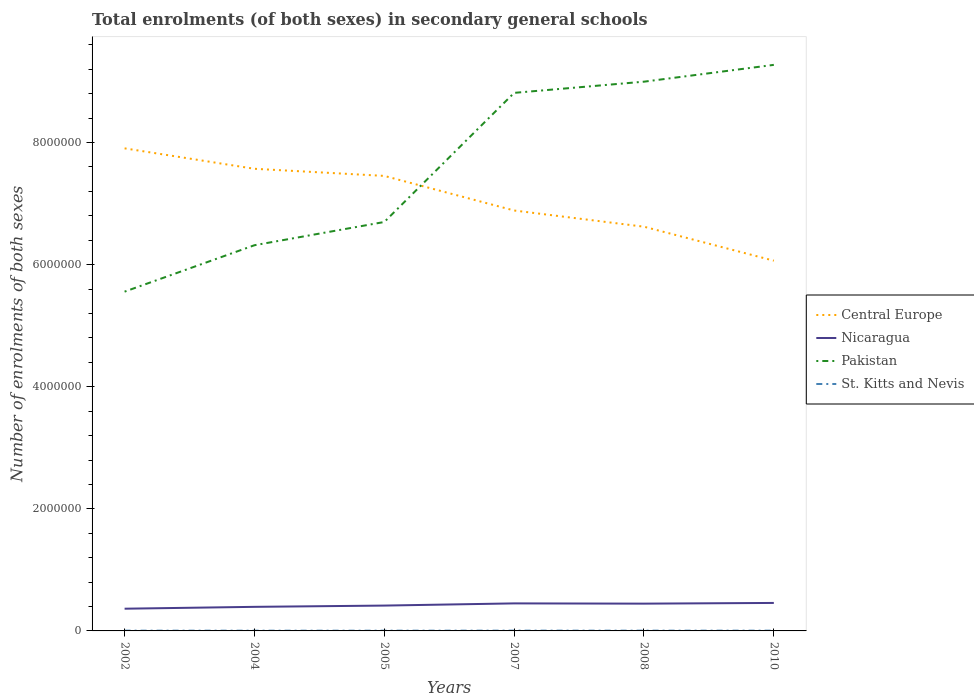Is the number of lines equal to the number of legend labels?
Give a very brief answer. Yes. Across all years, what is the maximum number of enrolments in secondary schools in Central Europe?
Your response must be concise. 6.07e+06. In which year was the number of enrolments in secondary schools in St. Kitts and Nevis maximum?
Provide a succinct answer. 2004. What is the total number of enrolments in secondary schools in Pakistan in the graph?
Offer a very short reply. -1.14e+06. What is the difference between the highest and the second highest number of enrolments in secondary schools in Pakistan?
Give a very brief answer. 3.72e+06. How many lines are there?
Your answer should be very brief. 4. Does the graph contain grids?
Give a very brief answer. No. Where does the legend appear in the graph?
Make the answer very short. Center right. How are the legend labels stacked?
Give a very brief answer. Vertical. What is the title of the graph?
Ensure brevity in your answer.  Total enrolments (of both sexes) in secondary general schools. Does "Vanuatu" appear as one of the legend labels in the graph?
Make the answer very short. No. What is the label or title of the X-axis?
Your answer should be very brief. Years. What is the label or title of the Y-axis?
Keep it short and to the point. Number of enrolments of both sexes. What is the Number of enrolments of both sexes in Central Europe in 2002?
Make the answer very short. 7.91e+06. What is the Number of enrolments of both sexes in Nicaragua in 2002?
Keep it short and to the point. 3.64e+05. What is the Number of enrolments of both sexes in Pakistan in 2002?
Offer a very short reply. 5.56e+06. What is the Number of enrolments of both sexes in St. Kitts and Nevis in 2002?
Your response must be concise. 4240. What is the Number of enrolments of both sexes in Central Europe in 2004?
Offer a very short reply. 7.57e+06. What is the Number of enrolments of both sexes in Nicaragua in 2004?
Keep it short and to the point. 3.94e+05. What is the Number of enrolments of both sexes in Pakistan in 2004?
Your response must be concise. 6.32e+06. What is the Number of enrolments of both sexes of St. Kitts and Nevis in 2004?
Provide a succinct answer. 3903. What is the Number of enrolments of both sexes in Central Europe in 2005?
Your answer should be very brief. 7.45e+06. What is the Number of enrolments of both sexes in Nicaragua in 2005?
Your answer should be very brief. 4.15e+05. What is the Number of enrolments of both sexes of Pakistan in 2005?
Provide a succinct answer. 6.70e+06. What is the Number of enrolments of both sexes of St. Kitts and Nevis in 2005?
Offer a terse response. 3939. What is the Number of enrolments of both sexes in Central Europe in 2007?
Keep it short and to the point. 6.89e+06. What is the Number of enrolments of both sexes of Nicaragua in 2007?
Keep it short and to the point. 4.51e+05. What is the Number of enrolments of both sexes in Pakistan in 2007?
Give a very brief answer. 8.81e+06. What is the Number of enrolments of both sexes in St. Kitts and Nevis in 2007?
Offer a very short reply. 4522. What is the Number of enrolments of both sexes of Central Europe in 2008?
Make the answer very short. 6.62e+06. What is the Number of enrolments of both sexes of Nicaragua in 2008?
Provide a short and direct response. 4.47e+05. What is the Number of enrolments of both sexes of Pakistan in 2008?
Provide a succinct answer. 9.00e+06. What is the Number of enrolments of both sexes of St. Kitts and Nevis in 2008?
Make the answer very short. 4396. What is the Number of enrolments of both sexes of Central Europe in 2010?
Keep it short and to the point. 6.07e+06. What is the Number of enrolments of both sexes in Nicaragua in 2010?
Offer a terse response. 4.58e+05. What is the Number of enrolments of both sexes in Pakistan in 2010?
Offer a terse response. 9.27e+06. What is the Number of enrolments of both sexes in St. Kitts and Nevis in 2010?
Provide a short and direct response. 4309. Across all years, what is the maximum Number of enrolments of both sexes in Central Europe?
Your response must be concise. 7.91e+06. Across all years, what is the maximum Number of enrolments of both sexes in Nicaragua?
Make the answer very short. 4.58e+05. Across all years, what is the maximum Number of enrolments of both sexes in Pakistan?
Your answer should be very brief. 9.27e+06. Across all years, what is the maximum Number of enrolments of both sexes of St. Kitts and Nevis?
Your answer should be compact. 4522. Across all years, what is the minimum Number of enrolments of both sexes of Central Europe?
Offer a very short reply. 6.07e+06. Across all years, what is the minimum Number of enrolments of both sexes in Nicaragua?
Give a very brief answer. 3.64e+05. Across all years, what is the minimum Number of enrolments of both sexes of Pakistan?
Offer a very short reply. 5.56e+06. Across all years, what is the minimum Number of enrolments of both sexes of St. Kitts and Nevis?
Keep it short and to the point. 3903. What is the total Number of enrolments of both sexes in Central Europe in the graph?
Offer a very short reply. 4.25e+07. What is the total Number of enrolments of both sexes in Nicaragua in the graph?
Offer a very short reply. 2.53e+06. What is the total Number of enrolments of both sexes of Pakistan in the graph?
Provide a succinct answer. 4.57e+07. What is the total Number of enrolments of both sexes in St. Kitts and Nevis in the graph?
Make the answer very short. 2.53e+04. What is the difference between the Number of enrolments of both sexes in Central Europe in 2002 and that in 2004?
Your answer should be very brief. 3.35e+05. What is the difference between the Number of enrolments of both sexes of Nicaragua in 2002 and that in 2004?
Your response must be concise. -3.03e+04. What is the difference between the Number of enrolments of both sexes of Pakistan in 2002 and that in 2004?
Ensure brevity in your answer.  -7.60e+05. What is the difference between the Number of enrolments of both sexes of St. Kitts and Nevis in 2002 and that in 2004?
Offer a very short reply. 337. What is the difference between the Number of enrolments of both sexes in Central Europe in 2002 and that in 2005?
Give a very brief answer. 4.51e+05. What is the difference between the Number of enrolments of both sexes of Nicaragua in 2002 and that in 2005?
Your response must be concise. -5.13e+04. What is the difference between the Number of enrolments of both sexes in Pakistan in 2002 and that in 2005?
Your response must be concise. -1.14e+06. What is the difference between the Number of enrolments of both sexes in St. Kitts and Nevis in 2002 and that in 2005?
Keep it short and to the point. 301. What is the difference between the Number of enrolments of both sexes of Central Europe in 2002 and that in 2007?
Your response must be concise. 1.02e+06. What is the difference between the Number of enrolments of both sexes of Nicaragua in 2002 and that in 2007?
Your answer should be very brief. -8.71e+04. What is the difference between the Number of enrolments of both sexes of Pakistan in 2002 and that in 2007?
Offer a very short reply. -3.26e+06. What is the difference between the Number of enrolments of both sexes of St. Kitts and Nevis in 2002 and that in 2007?
Offer a terse response. -282. What is the difference between the Number of enrolments of both sexes of Central Europe in 2002 and that in 2008?
Provide a short and direct response. 1.28e+06. What is the difference between the Number of enrolments of both sexes of Nicaragua in 2002 and that in 2008?
Ensure brevity in your answer.  -8.29e+04. What is the difference between the Number of enrolments of both sexes of Pakistan in 2002 and that in 2008?
Your response must be concise. -3.44e+06. What is the difference between the Number of enrolments of both sexes of St. Kitts and Nevis in 2002 and that in 2008?
Keep it short and to the point. -156. What is the difference between the Number of enrolments of both sexes in Central Europe in 2002 and that in 2010?
Your answer should be very brief. 1.84e+06. What is the difference between the Number of enrolments of both sexes of Nicaragua in 2002 and that in 2010?
Make the answer very short. -9.43e+04. What is the difference between the Number of enrolments of both sexes in Pakistan in 2002 and that in 2010?
Provide a succinct answer. -3.72e+06. What is the difference between the Number of enrolments of both sexes of St. Kitts and Nevis in 2002 and that in 2010?
Offer a terse response. -69. What is the difference between the Number of enrolments of both sexes in Central Europe in 2004 and that in 2005?
Your response must be concise. 1.17e+05. What is the difference between the Number of enrolments of both sexes in Nicaragua in 2004 and that in 2005?
Ensure brevity in your answer.  -2.09e+04. What is the difference between the Number of enrolments of both sexes in Pakistan in 2004 and that in 2005?
Ensure brevity in your answer.  -3.81e+05. What is the difference between the Number of enrolments of both sexes of St. Kitts and Nevis in 2004 and that in 2005?
Keep it short and to the point. -36. What is the difference between the Number of enrolments of both sexes in Central Europe in 2004 and that in 2007?
Offer a very short reply. 6.83e+05. What is the difference between the Number of enrolments of both sexes of Nicaragua in 2004 and that in 2007?
Keep it short and to the point. -5.67e+04. What is the difference between the Number of enrolments of both sexes in Pakistan in 2004 and that in 2007?
Provide a succinct answer. -2.50e+06. What is the difference between the Number of enrolments of both sexes of St. Kitts and Nevis in 2004 and that in 2007?
Provide a succinct answer. -619. What is the difference between the Number of enrolments of both sexes in Central Europe in 2004 and that in 2008?
Your answer should be very brief. 9.49e+05. What is the difference between the Number of enrolments of both sexes of Nicaragua in 2004 and that in 2008?
Your answer should be very brief. -5.25e+04. What is the difference between the Number of enrolments of both sexes of Pakistan in 2004 and that in 2008?
Ensure brevity in your answer.  -2.68e+06. What is the difference between the Number of enrolments of both sexes of St. Kitts and Nevis in 2004 and that in 2008?
Offer a terse response. -493. What is the difference between the Number of enrolments of both sexes of Central Europe in 2004 and that in 2010?
Offer a terse response. 1.51e+06. What is the difference between the Number of enrolments of both sexes in Nicaragua in 2004 and that in 2010?
Make the answer very short. -6.40e+04. What is the difference between the Number of enrolments of both sexes in Pakistan in 2004 and that in 2010?
Provide a succinct answer. -2.95e+06. What is the difference between the Number of enrolments of both sexes of St. Kitts and Nevis in 2004 and that in 2010?
Make the answer very short. -406. What is the difference between the Number of enrolments of both sexes in Central Europe in 2005 and that in 2007?
Offer a terse response. 5.67e+05. What is the difference between the Number of enrolments of both sexes in Nicaragua in 2005 and that in 2007?
Your answer should be compact. -3.58e+04. What is the difference between the Number of enrolments of both sexes in Pakistan in 2005 and that in 2007?
Offer a very short reply. -2.12e+06. What is the difference between the Number of enrolments of both sexes in St. Kitts and Nevis in 2005 and that in 2007?
Give a very brief answer. -583. What is the difference between the Number of enrolments of both sexes in Central Europe in 2005 and that in 2008?
Keep it short and to the point. 8.32e+05. What is the difference between the Number of enrolments of both sexes of Nicaragua in 2005 and that in 2008?
Offer a terse response. -3.16e+04. What is the difference between the Number of enrolments of both sexes of Pakistan in 2005 and that in 2008?
Keep it short and to the point. -2.30e+06. What is the difference between the Number of enrolments of both sexes in St. Kitts and Nevis in 2005 and that in 2008?
Provide a succinct answer. -457. What is the difference between the Number of enrolments of both sexes of Central Europe in 2005 and that in 2010?
Your response must be concise. 1.39e+06. What is the difference between the Number of enrolments of both sexes in Nicaragua in 2005 and that in 2010?
Your response must be concise. -4.30e+04. What is the difference between the Number of enrolments of both sexes of Pakistan in 2005 and that in 2010?
Offer a very short reply. -2.57e+06. What is the difference between the Number of enrolments of both sexes of St. Kitts and Nevis in 2005 and that in 2010?
Keep it short and to the point. -370. What is the difference between the Number of enrolments of both sexes in Central Europe in 2007 and that in 2008?
Keep it short and to the point. 2.65e+05. What is the difference between the Number of enrolments of both sexes in Nicaragua in 2007 and that in 2008?
Offer a terse response. 4215. What is the difference between the Number of enrolments of both sexes in Pakistan in 2007 and that in 2008?
Keep it short and to the point. -1.83e+05. What is the difference between the Number of enrolments of both sexes in St. Kitts and Nevis in 2007 and that in 2008?
Your answer should be compact. 126. What is the difference between the Number of enrolments of both sexes of Central Europe in 2007 and that in 2010?
Offer a terse response. 8.22e+05. What is the difference between the Number of enrolments of both sexes of Nicaragua in 2007 and that in 2010?
Keep it short and to the point. -7238. What is the difference between the Number of enrolments of both sexes of Pakistan in 2007 and that in 2010?
Offer a terse response. -4.59e+05. What is the difference between the Number of enrolments of both sexes of St. Kitts and Nevis in 2007 and that in 2010?
Make the answer very short. 213. What is the difference between the Number of enrolments of both sexes in Central Europe in 2008 and that in 2010?
Your answer should be very brief. 5.57e+05. What is the difference between the Number of enrolments of both sexes in Nicaragua in 2008 and that in 2010?
Ensure brevity in your answer.  -1.15e+04. What is the difference between the Number of enrolments of both sexes of Pakistan in 2008 and that in 2010?
Give a very brief answer. -2.75e+05. What is the difference between the Number of enrolments of both sexes of Central Europe in 2002 and the Number of enrolments of both sexes of Nicaragua in 2004?
Provide a succinct answer. 7.51e+06. What is the difference between the Number of enrolments of both sexes of Central Europe in 2002 and the Number of enrolments of both sexes of Pakistan in 2004?
Keep it short and to the point. 1.59e+06. What is the difference between the Number of enrolments of both sexes in Central Europe in 2002 and the Number of enrolments of both sexes in St. Kitts and Nevis in 2004?
Offer a terse response. 7.90e+06. What is the difference between the Number of enrolments of both sexes of Nicaragua in 2002 and the Number of enrolments of both sexes of Pakistan in 2004?
Your answer should be very brief. -5.95e+06. What is the difference between the Number of enrolments of both sexes of Nicaragua in 2002 and the Number of enrolments of both sexes of St. Kitts and Nevis in 2004?
Provide a succinct answer. 3.60e+05. What is the difference between the Number of enrolments of both sexes of Pakistan in 2002 and the Number of enrolments of both sexes of St. Kitts and Nevis in 2004?
Offer a terse response. 5.55e+06. What is the difference between the Number of enrolments of both sexes in Central Europe in 2002 and the Number of enrolments of both sexes in Nicaragua in 2005?
Your response must be concise. 7.49e+06. What is the difference between the Number of enrolments of both sexes in Central Europe in 2002 and the Number of enrolments of both sexes in Pakistan in 2005?
Ensure brevity in your answer.  1.21e+06. What is the difference between the Number of enrolments of both sexes in Central Europe in 2002 and the Number of enrolments of both sexes in St. Kitts and Nevis in 2005?
Keep it short and to the point. 7.90e+06. What is the difference between the Number of enrolments of both sexes in Nicaragua in 2002 and the Number of enrolments of both sexes in Pakistan in 2005?
Keep it short and to the point. -6.34e+06. What is the difference between the Number of enrolments of both sexes in Nicaragua in 2002 and the Number of enrolments of both sexes in St. Kitts and Nevis in 2005?
Your response must be concise. 3.60e+05. What is the difference between the Number of enrolments of both sexes in Pakistan in 2002 and the Number of enrolments of both sexes in St. Kitts and Nevis in 2005?
Offer a very short reply. 5.55e+06. What is the difference between the Number of enrolments of both sexes of Central Europe in 2002 and the Number of enrolments of both sexes of Nicaragua in 2007?
Your answer should be very brief. 7.45e+06. What is the difference between the Number of enrolments of both sexes in Central Europe in 2002 and the Number of enrolments of both sexes in Pakistan in 2007?
Provide a short and direct response. -9.09e+05. What is the difference between the Number of enrolments of both sexes in Central Europe in 2002 and the Number of enrolments of both sexes in St. Kitts and Nevis in 2007?
Ensure brevity in your answer.  7.90e+06. What is the difference between the Number of enrolments of both sexes of Nicaragua in 2002 and the Number of enrolments of both sexes of Pakistan in 2007?
Your answer should be compact. -8.45e+06. What is the difference between the Number of enrolments of both sexes of Nicaragua in 2002 and the Number of enrolments of both sexes of St. Kitts and Nevis in 2007?
Your answer should be compact. 3.59e+05. What is the difference between the Number of enrolments of both sexes in Pakistan in 2002 and the Number of enrolments of both sexes in St. Kitts and Nevis in 2007?
Your answer should be very brief. 5.55e+06. What is the difference between the Number of enrolments of both sexes of Central Europe in 2002 and the Number of enrolments of both sexes of Nicaragua in 2008?
Offer a terse response. 7.46e+06. What is the difference between the Number of enrolments of both sexes in Central Europe in 2002 and the Number of enrolments of both sexes in Pakistan in 2008?
Your answer should be very brief. -1.09e+06. What is the difference between the Number of enrolments of both sexes of Central Europe in 2002 and the Number of enrolments of both sexes of St. Kitts and Nevis in 2008?
Keep it short and to the point. 7.90e+06. What is the difference between the Number of enrolments of both sexes of Nicaragua in 2002 and the Number of enrolments of both sexes of Pakistan in 2008?
Ensure brevity in your answer.  -8.63e+06. What is the difference between the Number of enrolments of both sexes in Nicaragua in 2002 and the Number of enrolments of both sexes in St. Kitts and Nevis in 2008?
Your answer should be very brief. 3.60e+05. What is the difference between the Number of enrolments of both sexes in Pakistan in 2002 and the Number of enrolments of both sexes in St. Kitts and Nevis in 2008?
Your answer should be very brief. 5.55e+06. What is the difference between the Number of enrolments of both sexes in Central Europe in 2002 and the Number of enrolments of both sexes in Nicaragua in 2010?
Your answer should be compact. 7.45e+06. What is the difference between the Number of enrolments of both sexes of Central Europe in 2002 and the Number of enrolments of both sexes of Pakistan in 2010?
Give a very brief answer. -1.37e+06. What is the difference between the Number of enrolments of both sexes in Central Europe in 2002 and the Number of enrolments of both sexes in St. Kitts and Nevis in 2010?
Provide a succinct answer. 7.90e+06. What is the difference between the Number of enrolments of both sexes of Nicaragua in 2002 and the Number of enrolments of both sexes of Pakistan in 2010?
Your answer should be compact. -8.91e+06. What is the difference between the Number of enrolments of both sexes of Nicaragua in 2002 and the Number of enrolments of both sexes of St. Kitts and Nevis in 2010?
Provide a succinct answer. 3.60e+05. What is the difference between the Number of enrolments of both sexes in Pakistan in 2002 and the Number of enrolments of both sexes in St. Kitts and Nevis in 2010?
Your answer should be compact. 5.55e+06. What is the difference between the Number of enrolments of both sexes of Central Europe in 2004 and the Number of enrolments of both sexes of Nicaragua in 2005?
Offer a very short reply. 7.16e+06. What is the difference between the Number of enrolments of both sexes of Central Europe in 2004 and the Number of enrolments of both sexes of Pakistan in 2005?
Give a very brief answer. 8.72e+05. What is the difference between the Number of enrolments of both sexes of Central Europe in 2004 and the Number of enrolments of both sexes of St. Kitts and Nevis in 2005?
Your response must be concise. 7.57e+06. What is the difference between the Number of enrolments of both sexes in Nicaragua in 2004 and the Number of enrolments of both sexes in Pakistan in 2005?
Provide a short and direct response. -6.30e+06. What is the difference between the Number of enrolments of both sexes in Nicaragua in 2004 and the Number of enrolments of both sexes in St. Kitts and Nevis in 2005?
Ensure brevity in your answer.  3.90e+05. What is the difference between the Number of enrolments of both sexes of Pakistan in 2004 and the Number of enrolments of both sexes of St. Kitts and Nevis in 2005?
Your answer should be very brief. 6.31e+06. What is the difference between the Number of enrolments of both sexes of Central Europe in 2004 and the Number of enrolments of both sexes of Nicaragua in 2007?
Make the answer very short. 7.12e+06. What is the difference between the Number of enrolments of both sexes in Central Europe in 2004 and the Number of enrolments of both sexes in Pakistan in 2007?
Give a very brief answer. -1.24e+06. What is the difference between the Number of enrolments of both sexes in Central Europe in 2004 and the Number of enrolments of both sexes in St. Kitts and Nevis in 2007?
Give a very brief answer. 7.57e+06. What is the difference between the Number of enrolments of both sexes of Nicaragua in 2004 and the Number of enrolments of both sexes of Pakistan in 2007?
Provide a succinct answer. -8.42e+06. What is the difference between the Number of enrolments of both sexes in Nicaragua in 2004 and the Number of enrolments of both sexes in St. Kitts and Nevis in 2007?
Keep it short and to the point. 3.90e+05. What is the difference between the Number of enrolments of both sexes of Pakistan in 2004 and the Number of enrolments of both sexes of St. Kitts and Nevis in 2007?
Make the answer very short. 6.31e+06. What is the difference between the Number of enrolments of both sexes in Central Europe in 2004 and the Number of enrolments of both sexes in Nicaragua in 2008?
Ensure brevity in your answer.  7.12e+06. What is the difference between the Number of enrolments of both sexes of Central Europe in 2004 and the Number of enrolments of both sexes of Pakistan in 2008?
Your response must be concise. -1.43e+06. What is the difference between the Number of enrolments of both sexes in Central Europe in 2004 and the Number of enrolments of both sexes in St. Kitts and Nevis in 2008?
Offer a very short reply. 7.57e+06. What is the difference between the Number of enrolments of both sexes of Nicaragua in 2004 and the Number of enrolments of both sexes of Pakistan in 2008?
Your response must be concise. -8.60e+06. What is the difference between the Number of enrolments of both sexes of Nicaragua in 2004 and the Number of enrolments of both sexes of St. Kitts and Nevis in 2008?
Keep it short and to the point. 3.90e+05. What is the difference between the Number of enrolments of both sexes of Pakistan in 2004 and the Number of enrolments of both sexes of St. Kitts and Nevis in 2008?
Provide a short and direct response. 6.31e+06. What is the difference between the Number of enrolments of both sexes of Central Europe in 2004 and the Number of enrolments of both sexes of Nicaragua in 2010?
Provide a short and direct response. 7.11e+06. What is the difference between the Number of enrolments of both sexes of Central Europe in 2004 and the Number of enrolments of both sexes of Pakistan in 2010?
Offer a terse response. -1.70e+06. What is the difference between the Number of enrolments of both sexes in Central Europe in 2004 and the Number of enrolments of both sexes in St. Kitts and Nevis in 2010?
Your answer should be compact. 7.57e+06. What is the difference between the Number of enrolments of both sexes of Nicaragua in 2004 and the Number of enrolments of both sexes of Pakistan in 2010?
Provide a short and direct response. -8.88e+06. What is the difference between the Number of enrolments of both sexes in Nicaragua in 2004 and the Number of enrolments of both sexes in St. Kitts and Nevis in 2010?
Your answer should be very brief. 3.90e+05. What is the difference between the Number of enrolments of both sexes of Pakistan in 2004 and the Number of enrolments of both sexes of St. Kitts and Nevis in 2010?
Offer a very short reply. 6.31e+06. What is the difference between the Number of enrolments of both sexes in Central Europe in 2005 and the Number of enrolments of both sexes in Nicaragua in 2007?
Make the answer very short. 7.00e+06. What is the difference between the Number of enrolments of both sexes in Central Europe in 2005 and the Number of enrolments of both sexes in Pakistan in 2007?
Ensure brevity in your answer.  -1.36e+06. What is the difference between the Number of enrolments of both sexes in Central Europe in 2005 and the Number of enrolments of both sexes in St. Kitts and Nevis in 2007?
Make the answer very short. 7.45e+06. What is the difference between the Number of enrolments of both sexes of Nicaragua in 2005 and the Number of enrolments of both sexes of Pakistan in 2007?
Offer a terse response. -8.40e+06. What is the difference between the Number of enrolments of both sexes of Nicaragua in 2005 and the Number of enrolments of both sexes of St. Kitts and Nevis in 2007?
Ensure brevity in your answer.  4.11e+05. What is the difference between the Number of enrolments of both sexes in Pakistan in 2005 and the Number of enrolments of both sexes in St. Kitts and Nevis in 2007?
Offer a terse response. 6.69e+06. What is the difference between the Number of enrolments of both sexes of Central Europe in 2005 and the Number of enrolments of both sexes of Nicaragua in 2008?
Keep it short and to the point. 7.01e+06. What is the difference between the Number of enrolments of both sexes of Central Europe in 2005 and the Number of enrolments of both sexes of Pakistan in 2008?
Keep it short and to the point. -1.54e+06. What is the difference between the Number of enrolments of both sexes in Central Europe in 2005 and the Number of enrolments of both sexes in St. Kitts and Nevis in 2008?
Make the answer very short. 7.45e+06. What is the difference between the Number of enrolments of both sexes in Nicaragua in 2005 and the Number of enrolments of both sexes in Pakistan in 2008?
Make the answer very short. -8.58e+06. What is the difference between the Number of enrolments of both sexes in Nicaragua in 2005 and the Number of enrolments of both sexes in St. Kitts and Nevis in 2008?
Provide a short and direct response. 4.11e+05. What is the difference between the Number of enrolments of both sexes of Pakistan in 2005 and the Number of enrolments of both sexes of St. Kitts and Nevis in 2008?
Offer a terse response. 6.69e+06. What is the difference between the Number of enrolments of both sexes in Central Europe in 2005 and the Number of enrolments of both sexes in Nicaragua in 2010?
Ensure brevity in your answer.  7.00e+06. What is the difference between the Number of enrolments of both sexes of Central Europe in 2005 and the Number of enrolments of both sexes of Pakistan in 2010?
Provide a short and direct response. -1.82e+06. What is the difference between the Number of enrolments of both sexes in Central Europe in 2005 and the Number of enrolments of both sexes in St. Kitts and Nevis in 2010?
Your answer should be compact. 7.45e+06. What is the difference between the Number of enrolments of both sexes in Nicaragua in 2005 and the Number of enrolments of both sexes in Pakistan in 2010?
Provide a succinct answer. -8.86e+06. What is the difference between the Number of enrolments of both sexes of Nicaragua in 2005 and the Number of enrolments of both sexes of St. Kitts and Nevis in 2010?
Keep it short and to the point. 4.11e+05. What is the difference between the Number of enrolments of both sexes in Pakistan in 2005 and the Number of enrolments of both sexes in St. Kitts and Nevis in 2010?
Make the answer very short. 6.69e+06. What is the difference between the Number of enrolments of both sexes of Central Europe in 2007 and the Number of enrolments of both sexes of Nicaragua in 2008?
Provide a succinct answer. 6.44e+06. What is the difference between the Number of enrolments of both sexes of Central Europe in 2007 and the Number of enrolments of both sexes of Pakistan in 2008?
Provide a succinct answer. -2.11e+06. What is the difference between the Number of enrolments of both sexes in Central Europe in 2007 and the Number of enrolments of both sexes in St. Kitts and Nevis in 2008?
Provide a short and direct response. 6.88e+06. What is the difference between the Number of enrolments of both sexes in Nicaragua in 2007 and the Number of enrolments of both sexes in Pakistan in 2008?
Your answer should be compact. -8.55e+06. What is the difference between the Number of enrolments of both sexes of Nicaragua in 2007 and the Number of enrolments of both sexes of St. Kitts and Nevis in 2008?
Keep it short and to the point. 4.47e+05. What is the difference between the Number of enrolments of both sexes of Pakistan in 2007 and the Number of enrolments of both sexes of St. Kitts and Nevis in 2008?
Give a very brief answer. 8.81e+06. What is the difference between the Number of enrolments of both sexes of Central Europe in 2007 and the Number of enrolments of both sexes of Nicaragua in 2010?
Give a very brief answer. 6.43e+06. What is the difference between the Number of enrolments of both sexes of Central Europe in 2007 and the Number of enrolments of both sexes of Pakistan in 2010?
Give a very brief answer. -2.39e+06. What is the difference between the Number of enrolments of both sexes of Central Europe in 2007 and the Number of enrolments of both sexes of St. Kitts and Nevis in 2010?
Offer a terse response. 6.88e+06. What is the difference between the Number of enrolments of both sexes in Nicaragua in 2007 and the Number of enrolments of both sexes in Pakistan in 2010?
Offer a terse response. -8.82e+06. What is the difference between the Number of enrolments of both sexes in Nicaragua in 2007 and the Number of enrolments of both sexes in St. Kitts and Nevis in 2010?
Provide a succinct answer. 4.47e+05. What is the difference between the Number of enrolments of both sexes in Pakistan in 2007 and the Number of enrolments of both sexes in St. Kitts and Nevis in 2010?
Offer a terse response. 8.81e+06. What is the difference between the Number of enrolments of both sexes in Central Europe in 2008 and the Number of enrolments of both sexes in Nicaragua in 2010?
Offer a terse response. 6.16e+06. What is the difference between the Number of enrolments of both sexes in Central Europe in 2008 and the Number of enrolments of both sexes in Pakistan in 2010?
Provide a succinct answer. -2.65e+06. What is the difference between the Number of enrolments of both sexes in Central Europe in 2008 and the Number of enrolments of both sexes in St. Kitts and Nevis in 2010?
Give a very brief answer. 6.62e+06. What is the difference between the Number of enrolments of both sexes in Nicaragua in 2008 and the Number of enrolments of both sexes in Pakistan in 2010?
Ensure brevity in your answer.  -8.83e+06. What is the difference between the Number of enrolments of both sexes in Nicaragua in 2008 and the Number of enrolments of both sexes in St. Kitts and Nevis in 2010?
Ensure brevity in your answer.  4.43e+05. What is the difference between the Number of enrolments of both sexes in Pakistan in 2008 and the Number of enrolments of both sexes in St. Kitts and Nevis in 2010?
Ensure brevity in your answer.  8.99e+06. What is the average Number of enrolments of both sexes of Central Europe per year?
Provide a short and direct response. 7.08e+06. What is the average Number of enrolments of both sexes of Nicaragua per year?
Make the answer very short. 4.22e+05. What is the average Number of enrolments of both sexes in Pakistan per year?
Keep it short and to the point. 7.61e+06. What is the average Number of enrolments of both sexes in St. Kitts and Nevis per year?
Your answer should be very brief. 4218.17. In the year 2002, what is the difference between the Number of enrolments of both sexes in Central Europe and Number of enrolments of both sexes in Nicaragua?
Your answer should be very brief. 7.54e+06. In the year 2002, what is the difference between the Number of enrolments of both sexes of Central Europe and Number of enrolments of both sexes of Pakistan?
Offer a terse response. 2.35e+06. In the year 2002, what is the difference between the Number of enrolments of both sexes in Central Europe and Number of enrolments of both sexes in St. Kitts and Nevis?
Ensure brevity in your answer.  7.90e+06. In the year 2002, what is the difference between the Number of enrolments of both sexes of Nicaragua and Number of enrolments of both sexes of Pakistan?
Ensure brevity in your answer.  -5.19e+06. In the year 2002, what is the difference between the Number of enrolments of both sexes of Nicaragua and Number of enrolments of both sexes of St. Kitts and Nevis?
Your answer should be very brief. 3.60e+05. In the year 2002, what is the difference between the Number of enrolments of both sexes of Pakistan and Number of enrolments of both sexes of St. Kitts and Nevis?
Make the answer very short. 5.55e+06. In the year 2004, what is the difference between the Number of enrolments of both sexes in Central Europe and Number of enrolments of both sexes in Nicaragua?
Your answer should be compact. 7.18e+06. In the year 2004, what is the difference between the Number of enrolments of both sexes in Central Europe and Number of enrolments of both sexes in Pakistan?
Provide a short and direct response. 1.25e+06. In the year 2004, what is the difference between the Number of enrolments of both sexes of Central Europe and Number of enrolments of both sexes of St. Kitts and Nevis?
Offer a very short reply. 7.57e+06. In the year 2004, what is the difference between the Number of enrolments of both sexes in Nicaragua and Number of enrolments of both sexes in Pakistan?
Offer a terse response. -5.92e+06. In the year 2004, what is the difference between the Number of enrolments of both sexes in Nicaragua and Number of enrolments of both sexes in St. Kitts and Nevis?
Give a very brief answer. 3.90e+05. In the year 2004, what is the difference between the Number of enrolments of both sexes of Pakistan and Number of enrolments of both sexes of St. Kitts and Nevis?
Provide a short and direct response. 6.31e+06. In the year 2005, what is the difference between the Number of enrolments of both sexes in Central Europe and Number of enrolments of both sexes in Nicaragua?
Offer a terse response. 7.04e+06. In the year 2005, what is the difference between the Number of enrolments of both sexes of Central Europe and Number of enrolments of both sexes of Pakistan?
Your answer should be very brief. 7.55e+05. In the year 2005, what is the difference between the Number of enrolments of both sexes of Central Europe and Number of enrolments of both sexes of St. Kitts and Nevis?
Your answer should be very brief. 7.45e+06. In the year 2005, what is the difference between the Number of enrolments of both sexes of Nicaragua and Number of enrolments of both sexes of Pakistan?
Ensure brevity in your answer.  -6.28e+06. In the year 2005, what is the difference between the Number of enrolments of both sexes of Nicaragua and Number of enrolments of both sexes of St. Kitts and Nevis?
Your answer should be very brief. 4.11e+05. In the year 2005, what is the difference between the Number of enrolments of both sexes of Pakistan and Number of enrolments of both sexes of St. Kitts and Nevis?
Offer a terse response. 6.70e+06. In the year 2007, what is the difference between the Number of enrolments of both sexes of Central Europe and Number of enrolments of both sexes of Nicaragua?
Provide a short and direct response. 6.44e+06. In the year 2007, what is the difference between the Number of enrolments of both sexes in Central Europe and Number of enrolments of both sexes in Pakistan?
Your response must be concise. -1.93e+06. In the year 2007, what is the difference between the Number of enrolments of both sexes of Central Europe and Number of enrolments of both sexes of St. Kitts and Nevis?
Your answer should be very brief. 6.88e+06. In the year 2007, what is the difference between the Number of enrolments of both sexes in Nicaragua and Number of enrolments of both sexes in Pakistan?
Ensure brevity in your answer.  -8.36e+06. In the year 2007, what is the difference between the Number of enrolments of both sexes in Nicaragua and Number of enrolments of both sexes in St. Kitts and Nevis?
Provide a succinct answer. 4.47e+05. In the year 2007, what is the difference between the Number of enrolments of both sexes of Pakistan and Number of enrolments of both sexes of St. Kitts and Nevis?
Your answer should be compact. 8.81e+06. In the year 2008, what is the difference between the Number of enrolments of both sexes of Central Europe and Number of enrolments of both sexes of Nicaragua?
Give a very brief answer. 6.17e+06. In the year 2008, what is the difference between the Number of enrolments of both sexes in Central Europe and Number of enrolments of both sexes in Pakistan?
Offer a very short reply. -2.38e+06. In the year 2008, what is the difference between the Number of enrolments of both sexes in Central Europe and Number of enrolments of both sexes in St. Kitts and Nevis?
Give a very brief answer. 6.62e+06. In the year 2008, what is the difference between the Number of enrolments of both sexes in Nicaragua and Number of enrolments of both sexes in Pakistan?
Ensure brevity in your answer.  -8.55e+06. In the year 2008, what is the difference between the Number of enrolments of both sexes of Nicaragua and Number of enrolments of both sexes of St. Kitts and Nevis?
Your answer should be very brief. 4.42e+05. In the year 2008, what is the difference between the Number of enrolments of both sexes in Pakistan and Number of enrolments of both sexes in St. Kitts and Nevis?
Offer a terse response. 8.99e+06. In the year 2010, what is the difference between the Number of enrolments of both sexes of Central Europe and Number of enrolments of both sexes of Nicaragua?
Ensure brevity in your answer.  5.61e+06. In the year 2010, what is the difference between the Number of enrolments of both sexes of Central Europe and Number of enrolments of both sexes of Pakistan?
Ensure brevity in your answer.  -3.21e+06. In the year 2010, what is the difference between the Number of enrolments of both sexes in Central Europe and Number of enrolments of both sexes in St. Kitts and Nevis?
Ensure brevity in your answer.  6.06e+06. In the year 2010, what is the difference between the Number of enrolments of both sexes in Nicaragua and Number of enrolments of both sexes in Pakistan?
Offer a terse response. -8.81e+06. In the year 2010, what is the difference between the Number of enrolments of both sexes of Nicaragua and Number of enrolments of both sexes of St. Kitts and Nevis?
Make the answer very short. 4.54e+05. In the year 2010, what is the difference between the Number of enrolments of both sexes in Pakistan and Number of enrolments of both sexes in St. Kitts and Nevis?
Your response must be concise. 9.27e+06. What is the ratio of the Number of enrolments of both sexes of Central Europe in 2002 to that in 2004?
Your answer should be very brief. 1.04. What is the ratio of the Number of enrolments of both sexes of Nicaragua in 2002 to that in 2004?
Your answer should be very brief. 0.92. What is the ratio of the Number of enrolments of both sexes in Pakistan in 2002 to that in 2004?
Your answer should be very brief. 0.88. What is the ratio of the Number of enrolments of both sexes in St. Kitts and Nevis in 2002 to that in 2004?
Make the answer very short. 1.09. What is the ratio of the Number of enrolments of both sexes of Central Europe in 2002 to that in 2005?
Ensure brevity in your answer.  1.06. What is the ratio of the Number of enrolments of both sexes in Nicaragua in 2002 to that in 2005?
Offer a very short reply. 0.88. What is the ratio of the Number of enrolments of both sexes in Pakistan in 2002 to that in 2005?
Ensure brevity in your answer.  0.83. What is the ratio of the Number of enrolments of both sexes of St. Kitts and Nevis in 2002 to that in 2005?
Give a very brief answer. 1.08. What is the ratio of the Number of enrolments of both sexes of Central Europe in 2002 to that in 2007?
Ensure brevity in your answer.  1.15. What is the ratio of the Number of enrolments of both sexes of Nicaragua in 2002 to that in 2007?
Your answer should be compact. 0.81. What is the ratio of the Number of enrolments of both sexes of Pakistan in 2002 to that in 2007?
Offer a very short reply. 0.63. What is the ratio of the Number of enrolments of both sexes of St. Kitts and Nevis in 2002 to that in 2007?
Give a very brief answer. 0.94. What is the ratio of the Number of enrolments of both sexes of Central Europe in 2002 to that in 2008?
Offer a terse response. 1.19. What is the ratio of the Number of enrolments of both sexes in Nicaragua in 2002 to that in 2008?
Your answer should be very brief. 0.81. What is the ratio of the Number of enrolments of both sexes in Pakistan in 2002 to that in 2008?
Make the answer very short. 0.62. What is the ratio of the Number of enrolments of both sexes of St. Kitts and Nevis in 2002 to that in 2008?
Offer a very short reply. 0.96. What is the ratio of the Number of enrolments of both sexes in Central Europe in 2002 to that in 2010?
Keep it short and to the point. 1.3. What is the ratio of the Number of enrolments of both sexes of Nicaragua in 2002 to that in 2010?
Give a very brief answer. 0.79. What is the ratio of the Number of enrolments of both sexes of Pakistan in 2002 to that in 2010?
Your answer should be compact. 0.6. What is the ratio of the Number of enrolments of both sexes in Central Europe in 2004 to that in 2005?
Your response must be concise. 1.02. What is the ratio of the Number of enrolments of both sexes of Nicaragua in 2004 to that in 2005?
Ensure brevity in your answer.  0.95. What is the ratio of the Number of enrolments of both sexes in Pakistan in 2004 to that in 2005?
Keep it short and to the point. 0.94. What is the ratio of the Number of enrolments of both sexes of St. Kitts and Nevis in 2004 to that in 2005?
Your answer should be very brief. 0.99. What is the ratio of the Number of enrolments of both sexes in Central Europe in 2004 to that in 2007?
Your answer should be very brief. 1.1. What is the ratio of the Number of enrolments of both sexes in Nicaragua in 2004 to that in 2007?
Keep it short and to the point. 0.87. What is the ratio of the Number of enrolments of both sexes of Pakistan in 2004 to that in 2007?
Offer a terse response. 0.72. What is the ratio of the Number of enrolments of both sexes in St. Kitts and Nevis in 2004 to that in 2007?
Provide a succinct answer. 0.86. What is the ratio of the Number of enrolments of both sexes of Central Europe in 2004 to that in 2008?
Provide a short and direct response. 1.14. What is the ratio of the Number of enrolments of both sexes in Nicaragua in 2004 to that in 2008?
Keep it short and to the point. 0.88. What is the ratio of the Number of enrolments of both sexes of Pakistan in 2004 to that in 2008?
Ensure brevity in your answer.  0.7. What is the ratio of the Number of enrolments of both sexes of St. Kitts and Nevis in 2004 to that in 2008?
Provide a short and direct response. 0.89. What is the ratio of the Number of enrolments of both sexes of Central Europe in 2004 to that in 2010?
Make the answer very short. 1.25. What is the ratio of the Number of enrolments of both sexes in Nicaragua in 2004 to that in 2010?
Your response must be concise. 0.86. What is the ratio of the Number of enrolments of both sexes in Pakistan in 2004 to that in 2010?
Make the answer very short. 0.68. What is the ratio of the Number of enrolments of both sexes in St. Kitts and Nevis in 2004 to that in 2010?
Give a very brief answer. 0.91. What is the ratio of the Number of enrolments of both sexes in Central Europe in 2005 to that in 2007?
Offer a terse response. 1.08. What is the ratio of the Number of enrolments of both sexes in Nicaragua in 2005 to that in 2007?
Your response must be concise. 0.92. What is the ratio of the Number of enrolments of both sexes in Pakistan in 2005 to that in 2007?
Your answer should be compact. 0.76. What is the ratio of the Number of enrolments of both sexes of St. Kitts and Nevis in 2005 to that in 2007?
Your answer should be very brief. 0.87. What is the ratio of the Number of enrolments of both sexes of Central Europe in 2005 to that in 2008?
Your answer should be very brief. 1.13. What is the ratio of the Number of enrolments of both sexes in Nicaragua in 2005 to that in 2008?
Your answer should be very brief. 0.93. What is the ratio of the Number of enrolments of both sexes of Pakistan in 2005 to that in 2008?
Offer a terse response. 0.74. What is the ratio of the Number of enrolments of both sexes of St. Kitts and Nevis in 2005 to that in 2008?
Your answer should be compact. 0.9. What is the ratio of the Number of enrolments of both sexes of Central Europe in 2005 to that in 2010?
Your answer should be very brief. 1.23. What is the ratio of the Number of enrolments of both sexes in Nicaragua in 2005 to that in 2010?
Keep it short and to the point. 0.91. What is the ratio of the Number of enrolments of both sexes in Pakistan in 2005 to that in 2010?
Provide a succinct answer. 0.72. What is the ratio of the Number of enrolments of both sexes of St. Kitts and Nevis in 2005 to that in 2010?
Keep it short and to the point. 0.91. What is the ratio of the Number of enrolments of both sexes of Central Europe in 2007 to that in 2008?
Keep it short and to the point. 1.04. What is the ratio of the Number of enrolments of both sexes in Nicaragua in 2007 to that in 2008?
Give a very brief answer. 1.01. What is the ratio of the Number of enrolments of both sexes of Pakistan in 2007 to that in 2008?
Your answer should be very brief. 0.98. What is the ratio of the Number of enrolments of both sexes of St. Kitts and Nevis in 2007 to that in 2008?
Make the answer very short. 1.03. What is the ratio of the Number of enrolments of both sexes of Central Europe in 2007 to that in 2010?
Keep it short and to the point. 1.14. What is the ratio of the Number of enrolments of both sexes of Nicaragua in 2007 to that in 2010?
Provide a short and direct response. 0.98. What is the ratio of the Number of enrolments of both sexes in Pakistan in 2007 to that in 2010?
Your response must be concise. 0.95. What is the ratio of the Number of enrolments of both sexes in St. Kitts and Nevis in 2007 to that in 2010?
Make the answer very short. 1.05. What is the ratio of the Number of enrolments of both sexes in Central Europe in 2008 to that in 2010?
Offer a very short reply. 1.09. What is the ratio of the Number of enrolments of both sexes in Nicaragua in 2008 to that in 2010?
Offer a terse response. 0.97. What is the ratio of the Number of enrolments of both sexes of Pakistan in 2008 to that in 2010?
Give a very brief answer. 0.97. What is the ratio of the Number of enrolments of both sexes of St. Kitts and Nevis in 2008 to that in 2010?
Provide a succinct answer. 1.02. What is the difference between the highest and the second highest Number of enrolments of both sexes in Central Europe?
Keep it short and to the point. 3.35e+05. What is the difference between the highest and the second highest Number of enrolments of both sexes in Nicaragua?
Your response must be concise. 7238. What is the difference between the highest and the second highest Number of enrolments of both sexes of Pakistan?
Offer a terse response. 2.75e+05. What is the difference between the highest and the second highest Number of enrolments of both sexes in St. Kitts and Nevis?
Provide a short and direct response. 126. What is the difference between the highest and the lowest Number of enrolments of both sexes of Central Europe?
Offer a terse response. 1.84e+06. What is the difference between the highest and the lowest Number of enrolments of both sexes in Nicaragua?
Provide a succinct answer. 9.43e+04. What is the difference between the highest and the lowest Number of enrolments of both sexes in Pakistan?
Ensure brevity in your answer.  3.72e+06. What is the difference between the highest and the lowest Number of enrolments of both sexes in St. Kitts and Nevis?
Your answer should be compact. 619. 